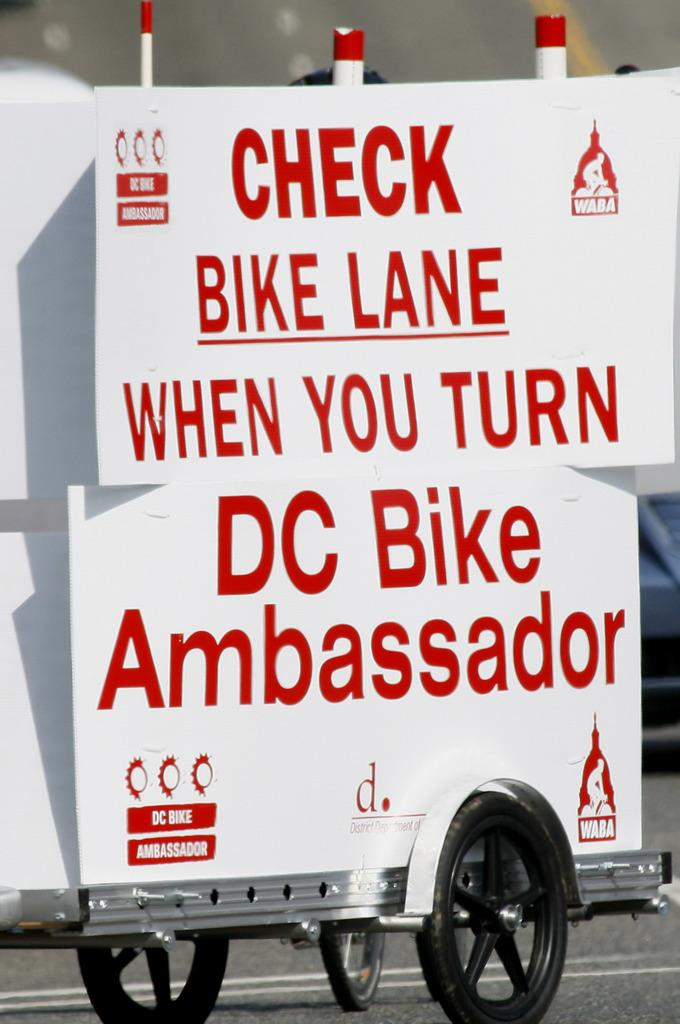What type of boards are present in the image? There are white boards in the image. What is on the white boards? There is writing on the white boards. What color is the writing on the white boards? The writing is in red color. What is the taste of the loss experienced by the person in the image? There is no person or loss present in the image, so it is not possible to determine the taste of any loss. 